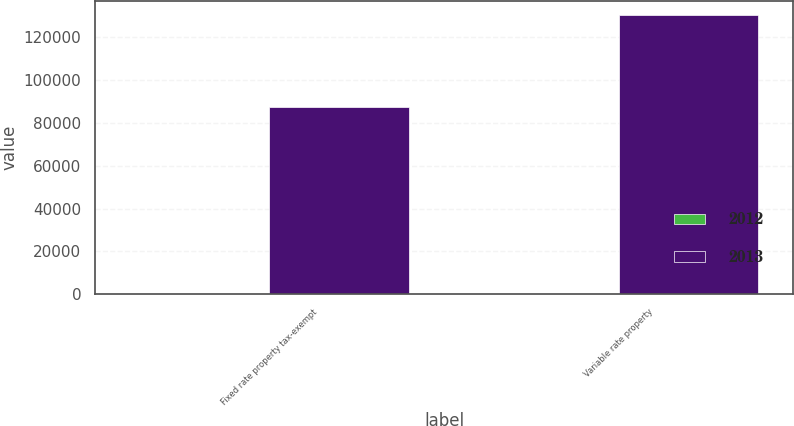Convert chart. <chart><loc_0><loc_0><loc_500><loc_500><stacked_bar_chart><ecel><fcel>Fixed rate property tax-exempt<fcel>Variable rate property<nl><fcel>2012<fcel>4.87<fcel>1.09<nl><fcel>2013<fcel>87220<fcel>130599<nl></chart> 